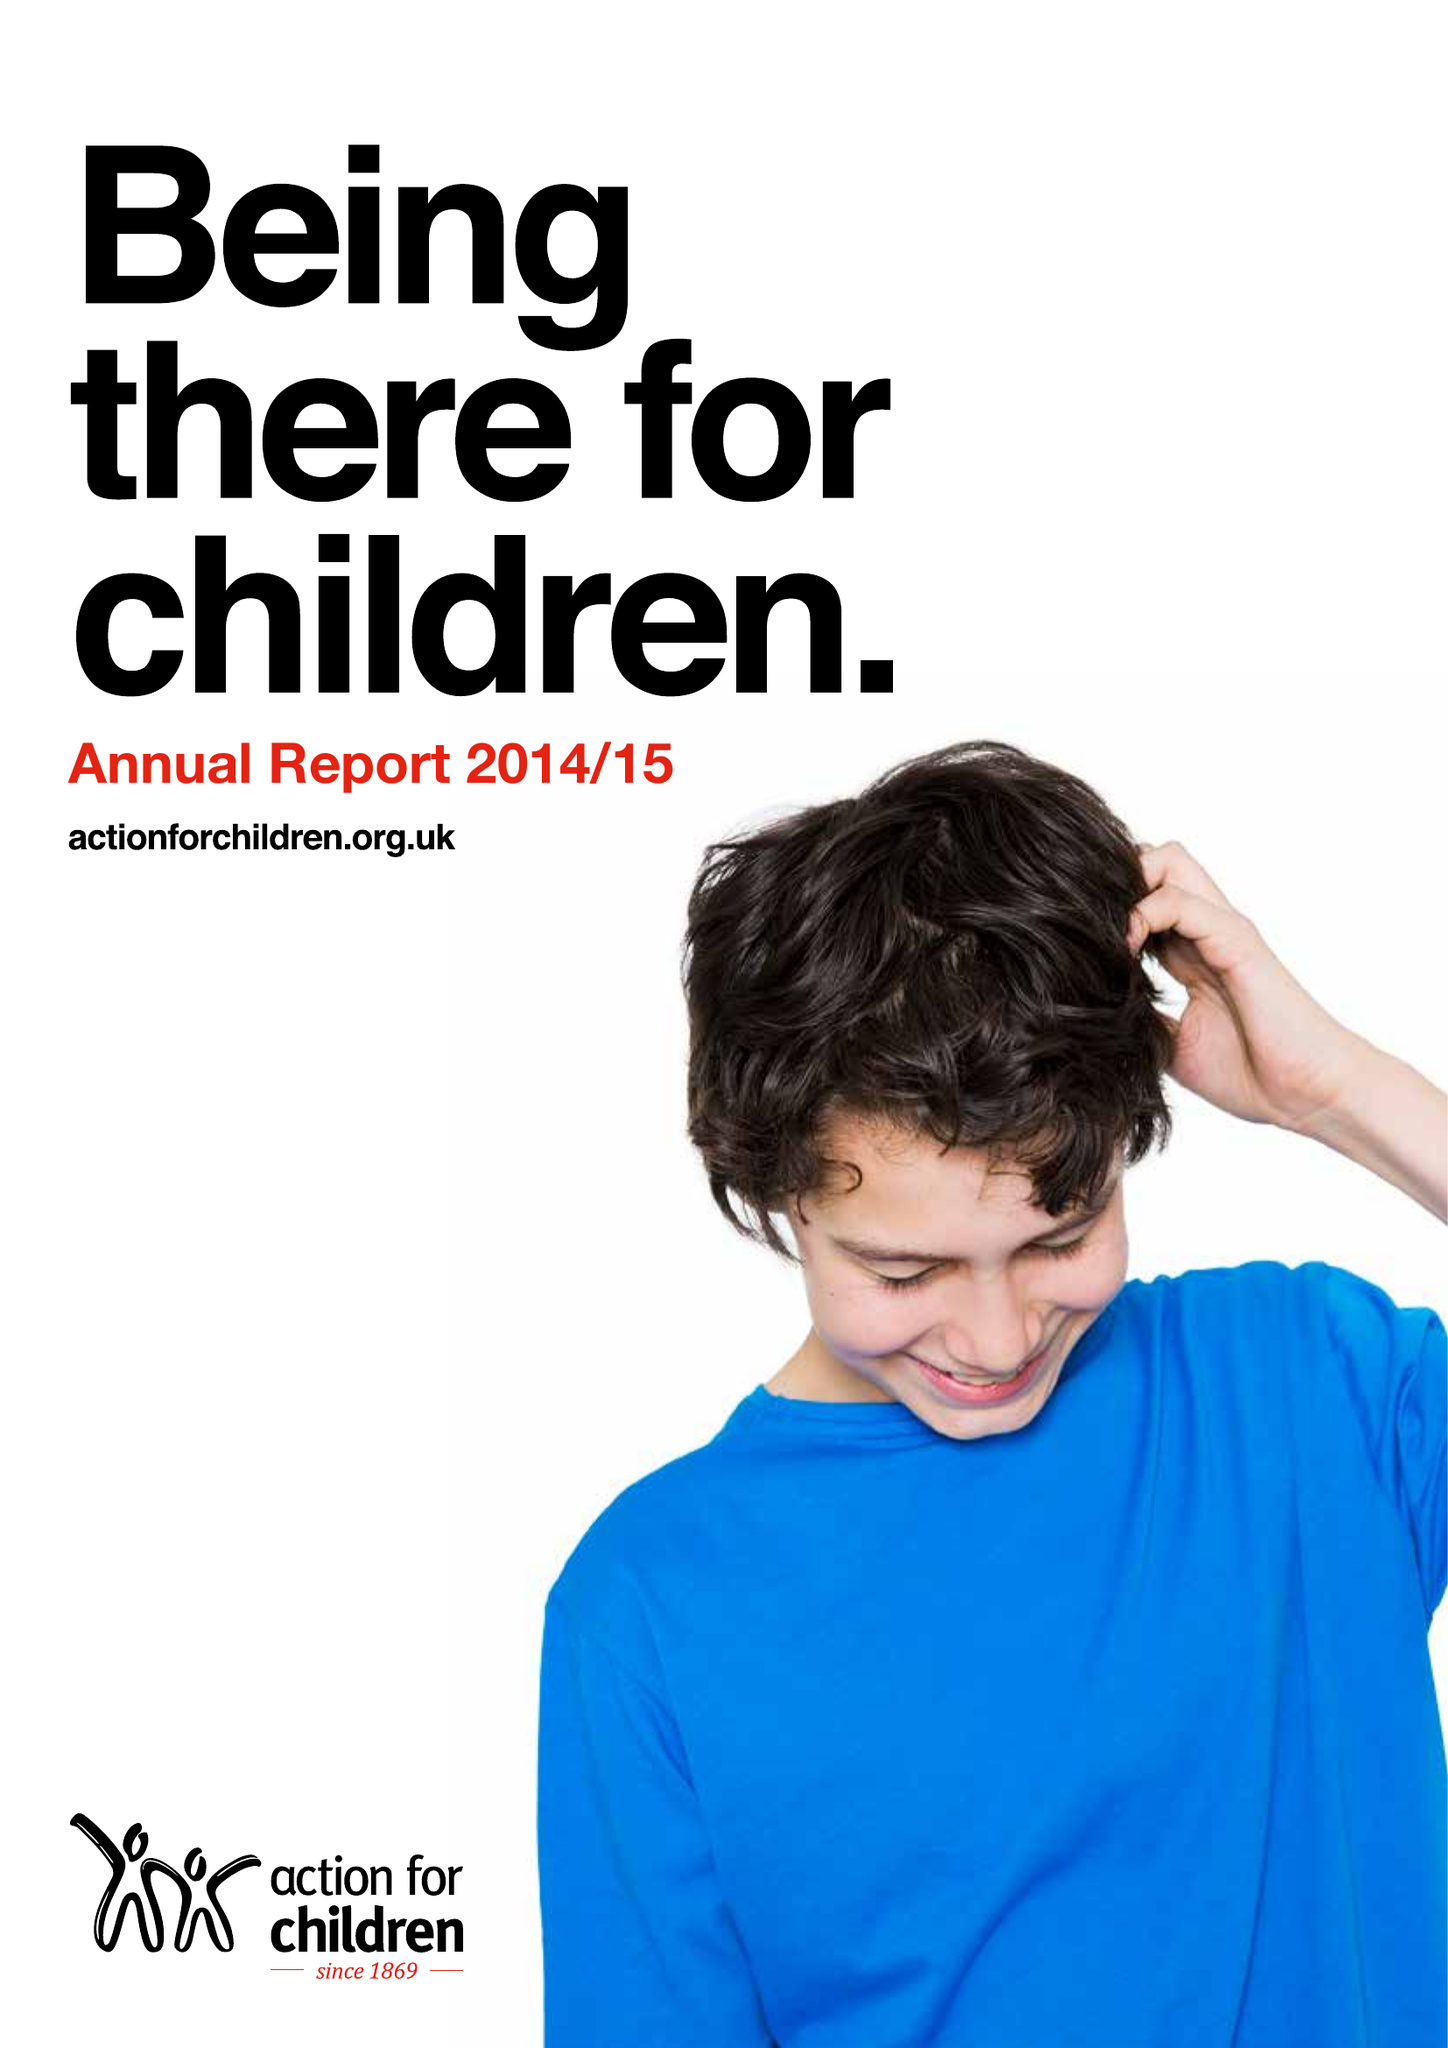What is the value for the income_annually_in_british_pounds?
Answer the question using a single word or phrase. 173070000.00 